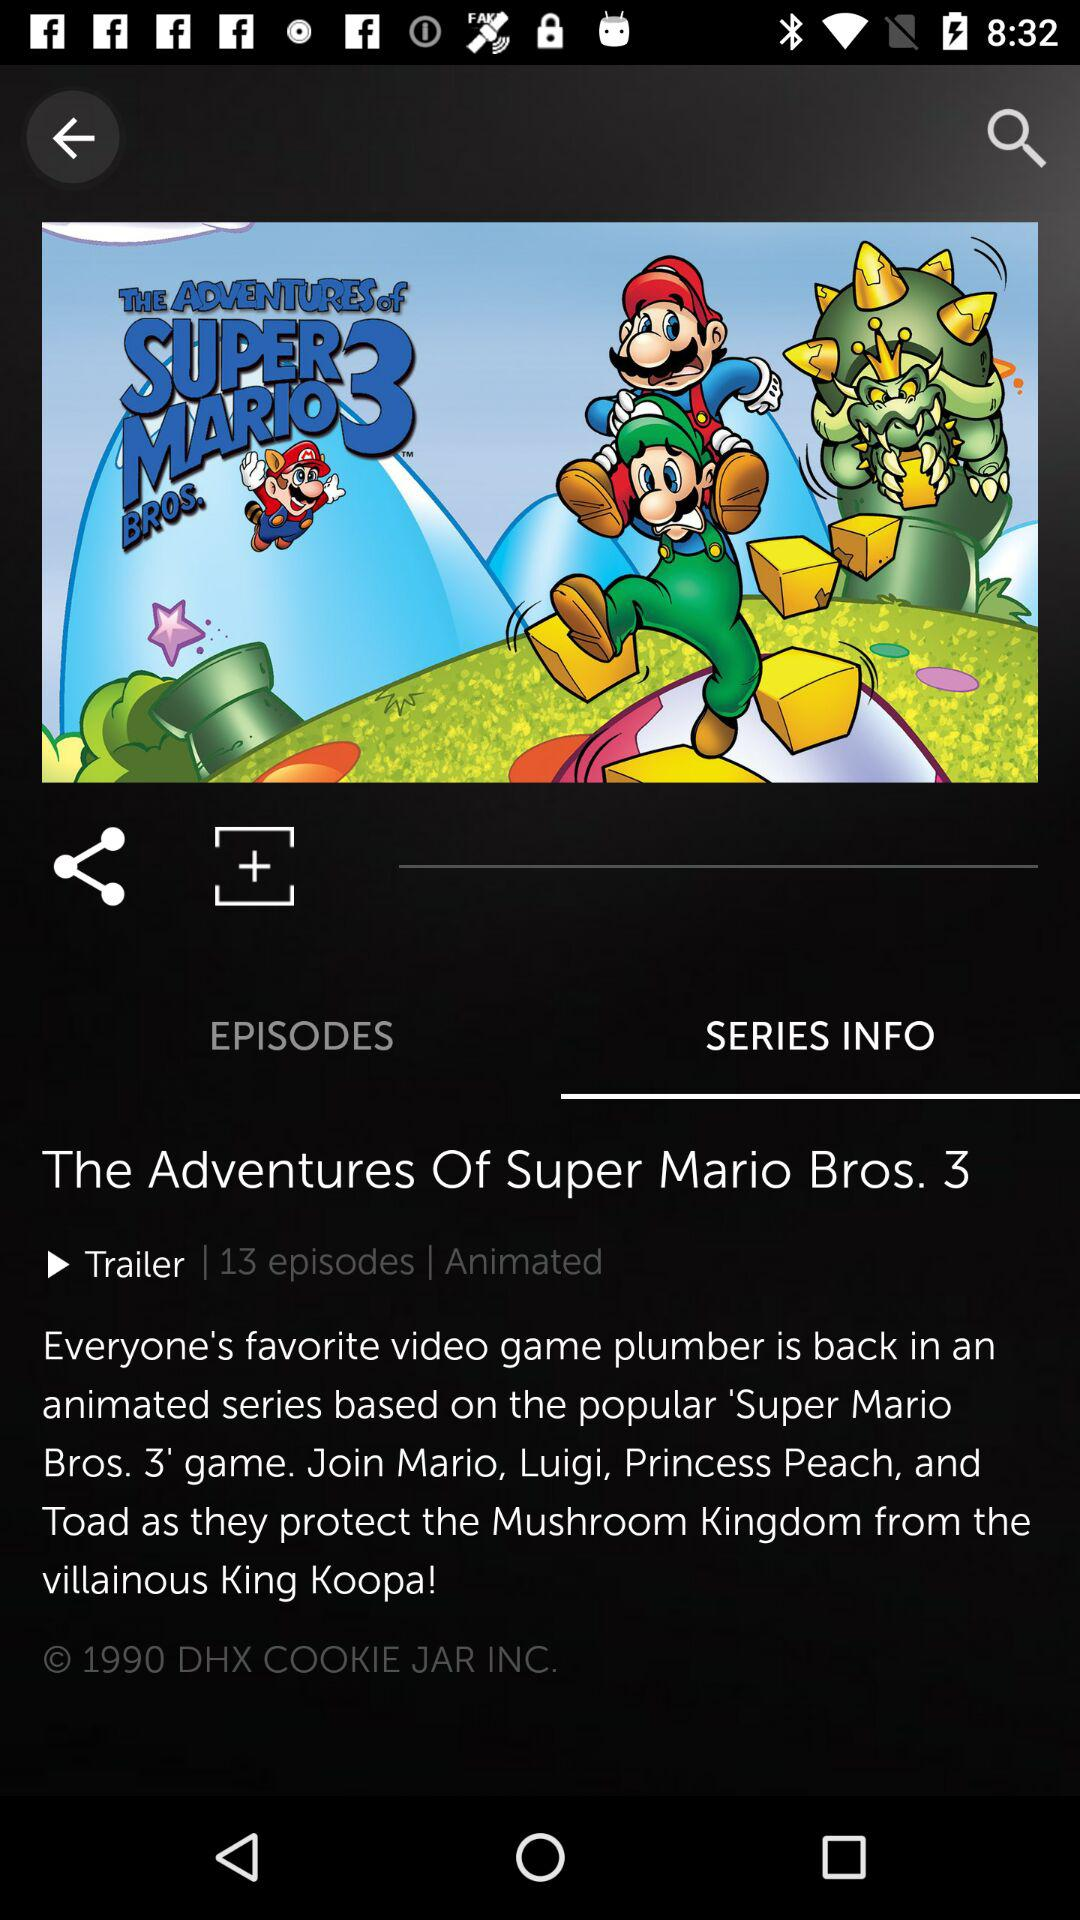What is the name of the series? The name of the series is "The Adventures Of Super Mario Bros. 3". 